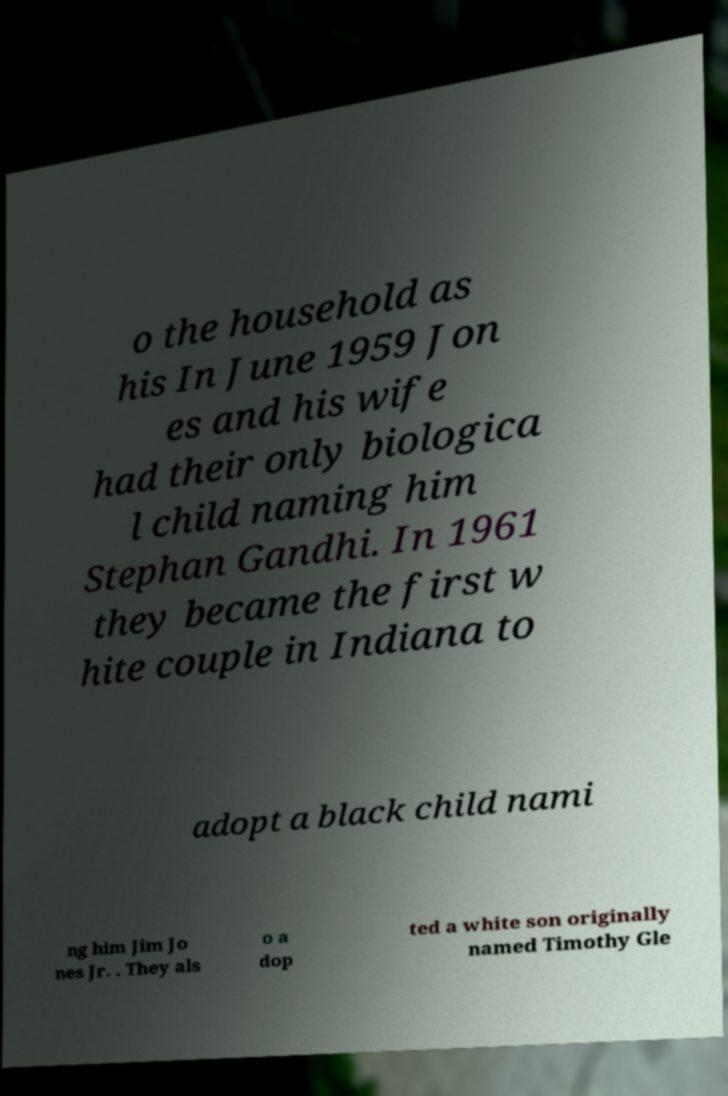Please identify and transcribe the text found in this image. o the household as his In June 1959 Jon es and his wife had their only biologica l child naming him Stephan Gandhi. In 1961 they became the first w hite couple in Indiana to adopt a black child nami ng him Jim Jo nes Jr. . They als o a dop ted a white son originally named Timothy Gle 